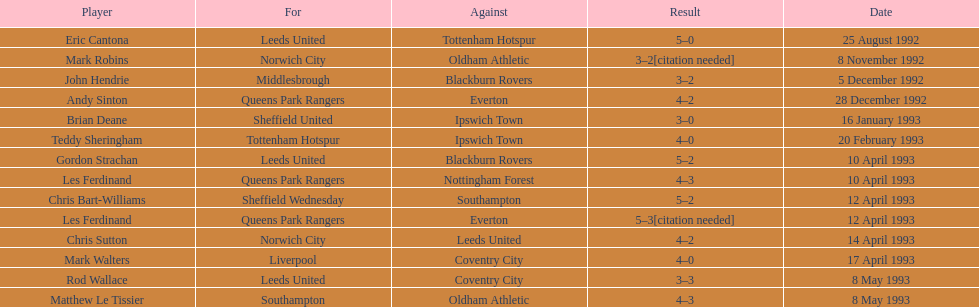What was the outcome of the game between queens park rangers and everton? 4-2. 